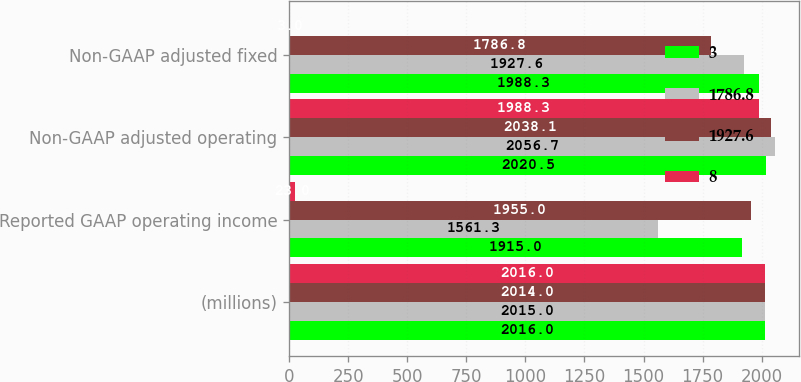Convert chart to OTSL. <chart><loc_0><loc_0><loc_500><loc_500><stacked_bar_chart><ecel><fcel>(millions)<fcel>Reported GAAP operating income<fcel>Non-GAAP adjusted operating<fcel>Non-GAAP adjusted fixed<nl><fcel>3<fcel>2016<fcel>1915<fcel>2020.5<fcel>1988.3<nl><fcel>1786.8<fcel>2015<fcel>1561.3<fcel>2056.7<fcel>1927.6<nl><fcel>1927.6<fcel>2014<fcel>1955<fcel>2038.1<fcel>1786.8<nl><fcel>8<fcel>2016<fcel>23<fcel>1988.3<fcel>3<nl></chart> 